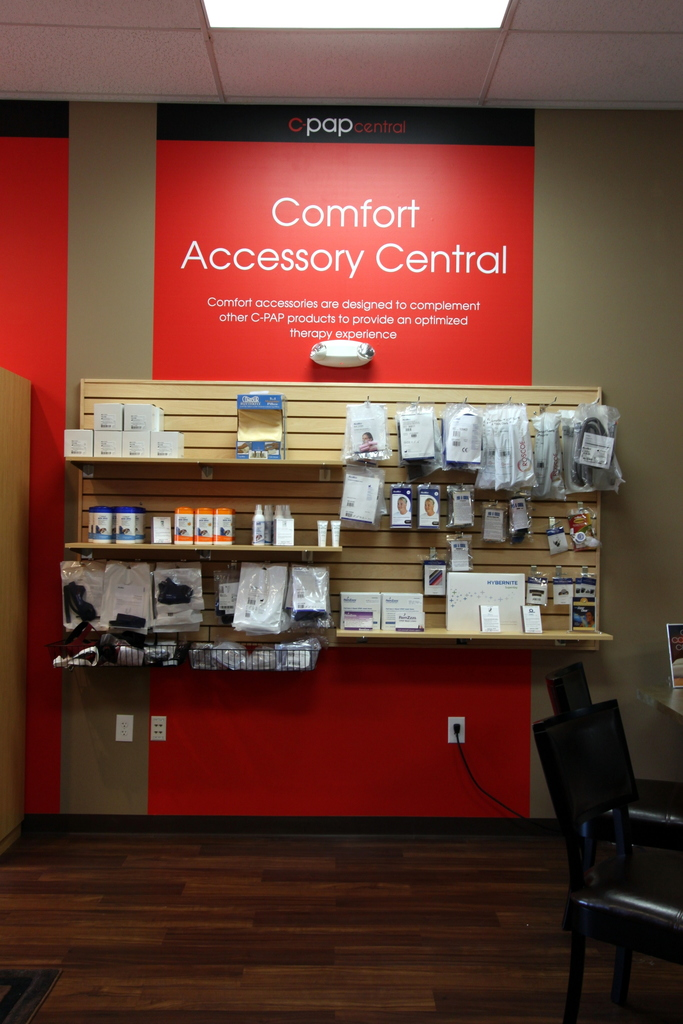What types of products are displayed on the shelves, and for what purpose are they used? The shelves contain various CPAP therapy products such as masks, hoses, and filters, all designed to improve the comfort and effectiveness of sleep apnea treatment. Can you describe any specific product shown in the image that stands out? One noticeable product is the 'Hybrid' mask on the lower shelf, which combines the benefits of a nasal pillow and a full-face mask, aimed at providing versatility and comfort. 